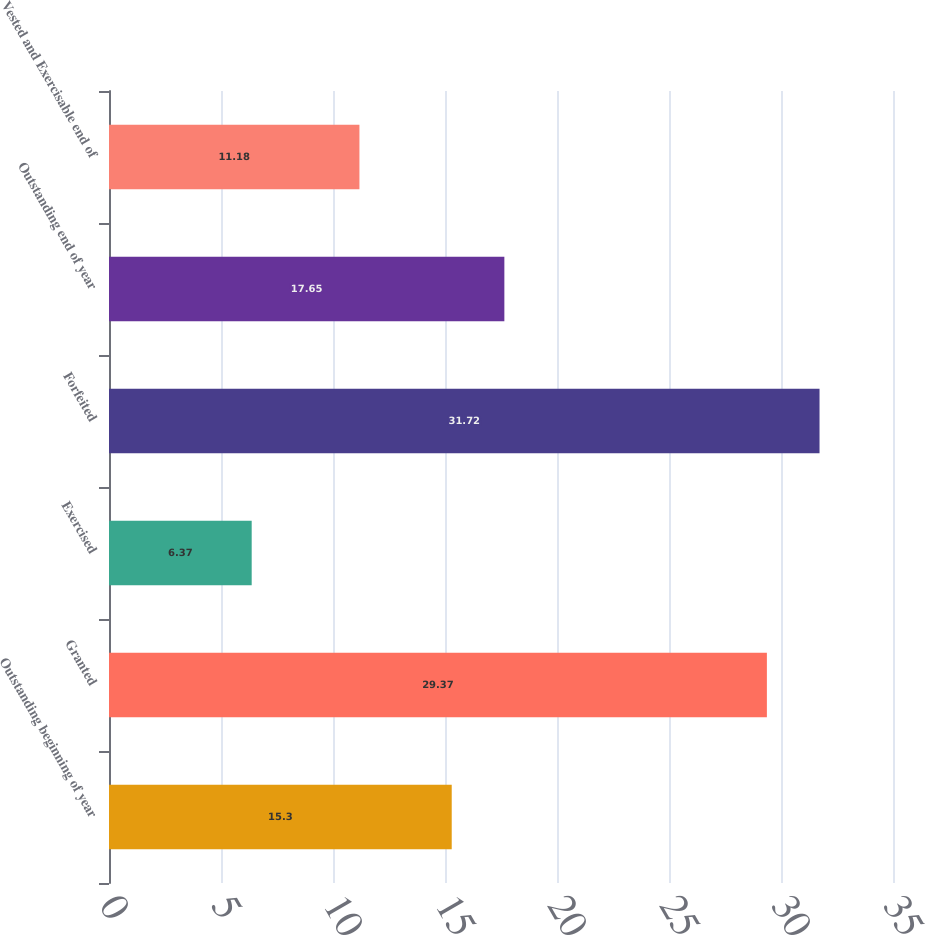Convert chart to OTSL. <chart><loc_0><loc_0><loc_500><loc_500><bar_chart><fcel>Outstanding beginning of year<fcel>Granted<fcel>Exercised<fcel>Forfeited<fcel>Outstanding end of year<fcel>Vested and Exercisable end of<nl><fcel>15.3<fcel>29.37<fcel>6.37<fcel>31.72<fcel>17.65<fcel>11.18<nl></chart> 